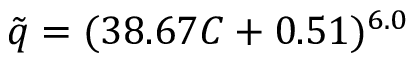Convert formula to latex. <formula><loc_0><loc_0><loc_500><loc_500>\tilde { q } = ( 3 8 . 6 7 C + 0 . 5 1 ) ^ { 6 . 0 }</formula> 